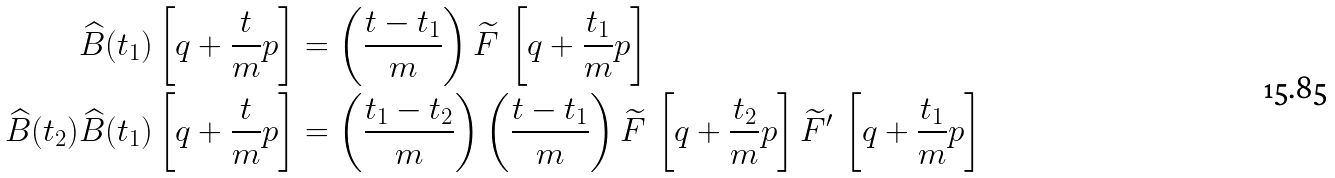<formula> <loc_0><loc_0><loc_500><loc_500>\widehat { B } ( t _ { 1 } ) \left [ q + \frac { t } { m } p \right ] & = \left ( \frac { t - t _ { 1 } } { m } \right ) \widetilde { F } \, \left [ q + \frac { t _ { 1 } } { m } p \right ] \\ \widehat { B } ( t _ { 2 } ) \widehat { B } ( t _ { 1 } ) \left [ q + \frac { t } { m } p \right ] & = \left ( \frac { t _ { 1 } - t _ { 2 } } { m } \right ) \left ( \frac { t - t _ { 1 } } { m } \right ) \widetilde { F } \, \left [ q + \frac { t _ { 2 } } { m } p \right ] \widetilde { F } ^ { \prime } \, \left [ q + \frac { t _ { 1 } } { m } p \right ]</formula> 